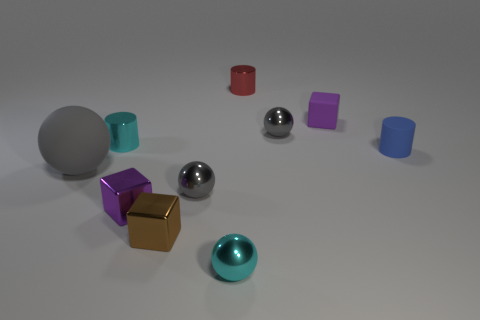Which object in the image is the largest? The largest object in the image appears to be the grey sphere on the left side. 